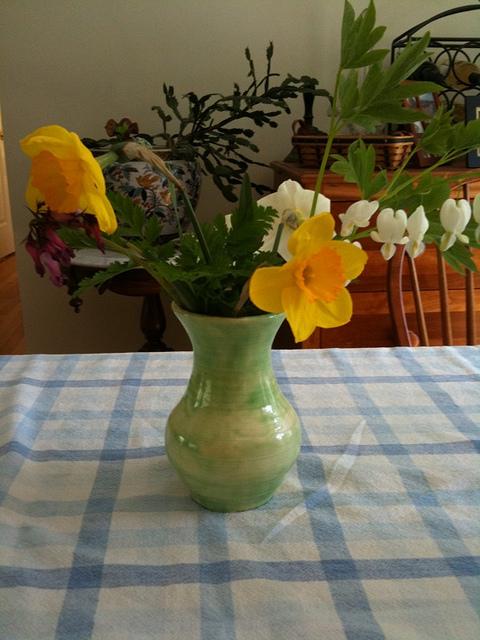What color is the table?
Write a very short answer. Blue and white. What color is the vase?
Short answer required. Green. Is the table cloth wrinkled?
Concise answer only. Yes. Are all daffodils yellow?
Keep it brief. No. 